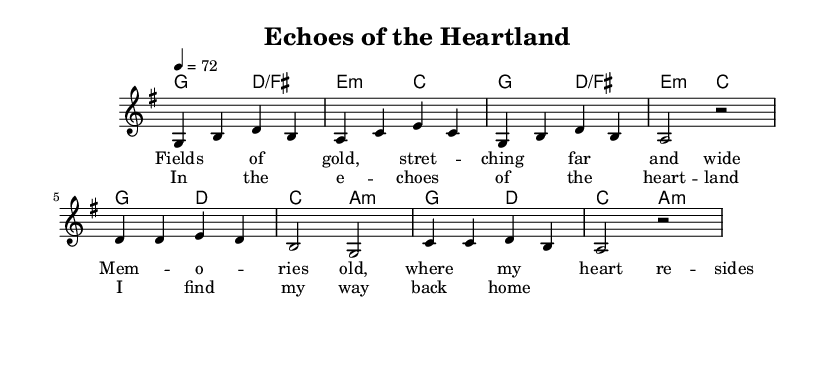What is the key signature of this music? The key signature is G major, which has one sharp (F#).
Answer: G major What is the time signature of this piece? The time signature is 4/4, indicating four beats per measure.
Answer: 4/4 What is the tempo marking for the piece? The tempo marking is a quarter note equals seventy-two beats per minute.
Answer: 72 How many measures are there in the verse section? The verse consists of four measures, as indicated by the grouping of notes.
Answer: 4 What type of harmony is used in the chorus? The chorus employs a mix of major and minor chords, characteristic of country rock.
Answer: Major and minor In which section do the lyrics "In the echoes of the heartland" appear? This lyric appears in the chorus, which follows the verse in structure.
Answer: Chorus What technique could enhance a live performance of this piece? Live looping techniques can be used to layer the acoustic guitar and vocals, adding depth to the arrangement.
Answer: Live looping 